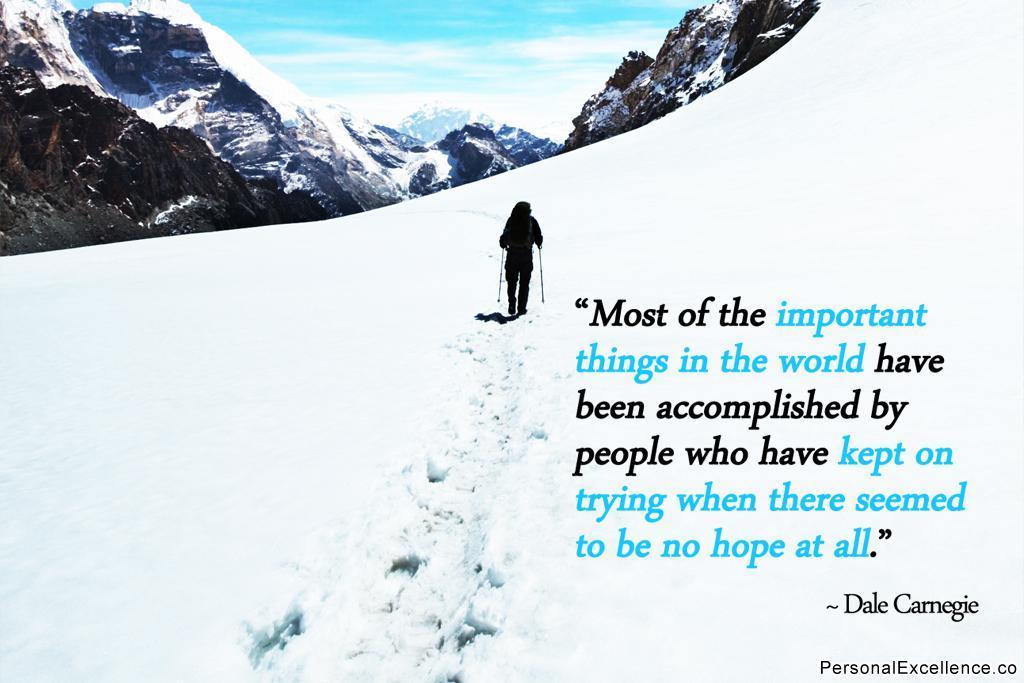Please provide a concise description of this image. In this image, we can see a person holding some objects. We can see the ground with snow. There are a few hills. We can see the sky with clouds. We can also see some text on the right. 